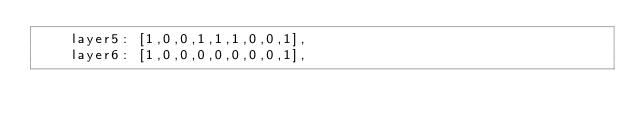<code> <loc_0><loc_0><loc_500><loc_500><_JavaScript_>    layer5: [1,0,0,1,1,1,0,0,1],
    layer6: [1,0,0,0,0,0,0,0,1],</code> 